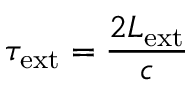<formula> <loc_0><loc_0><loc_500><loc_500>\tau _ { e x t } = \frac { 2 L _ { e x t } } { c }</formula> 